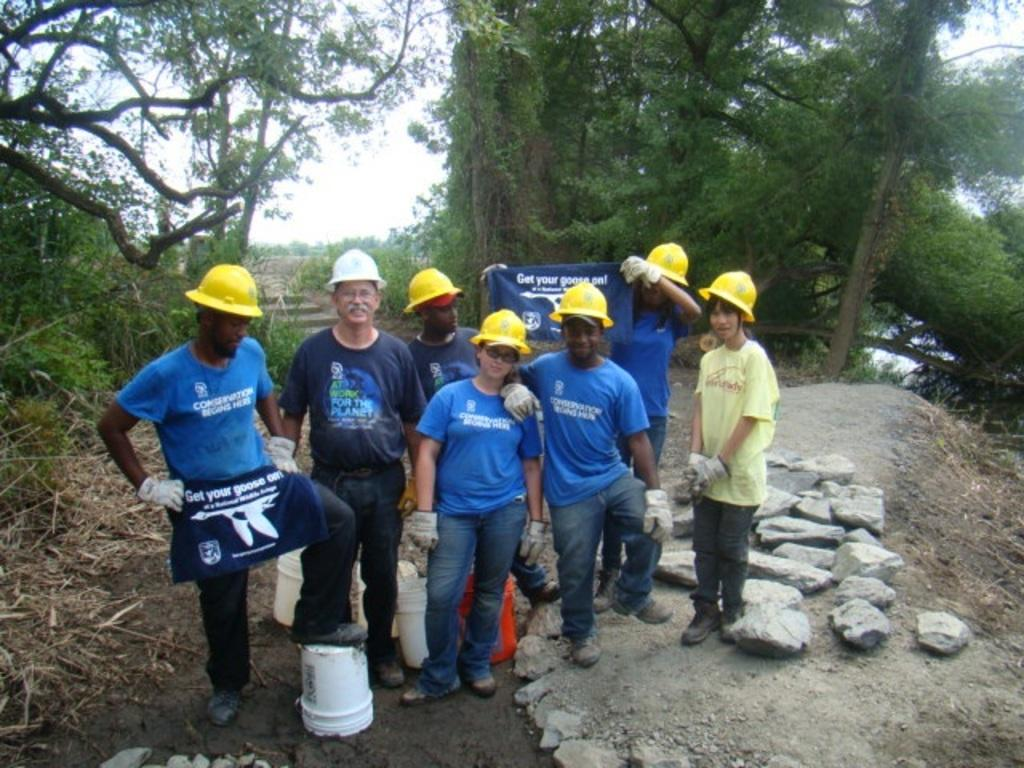<image>
Summarize the visual content of the image. A man wears an apron that reads "get your goose on." 